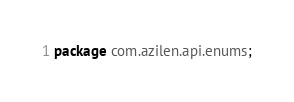Convert code to text. <code><loc_0><loc_0><loc_500><loc_500><_Java_>package com.azilen.api.enums;
</code> 